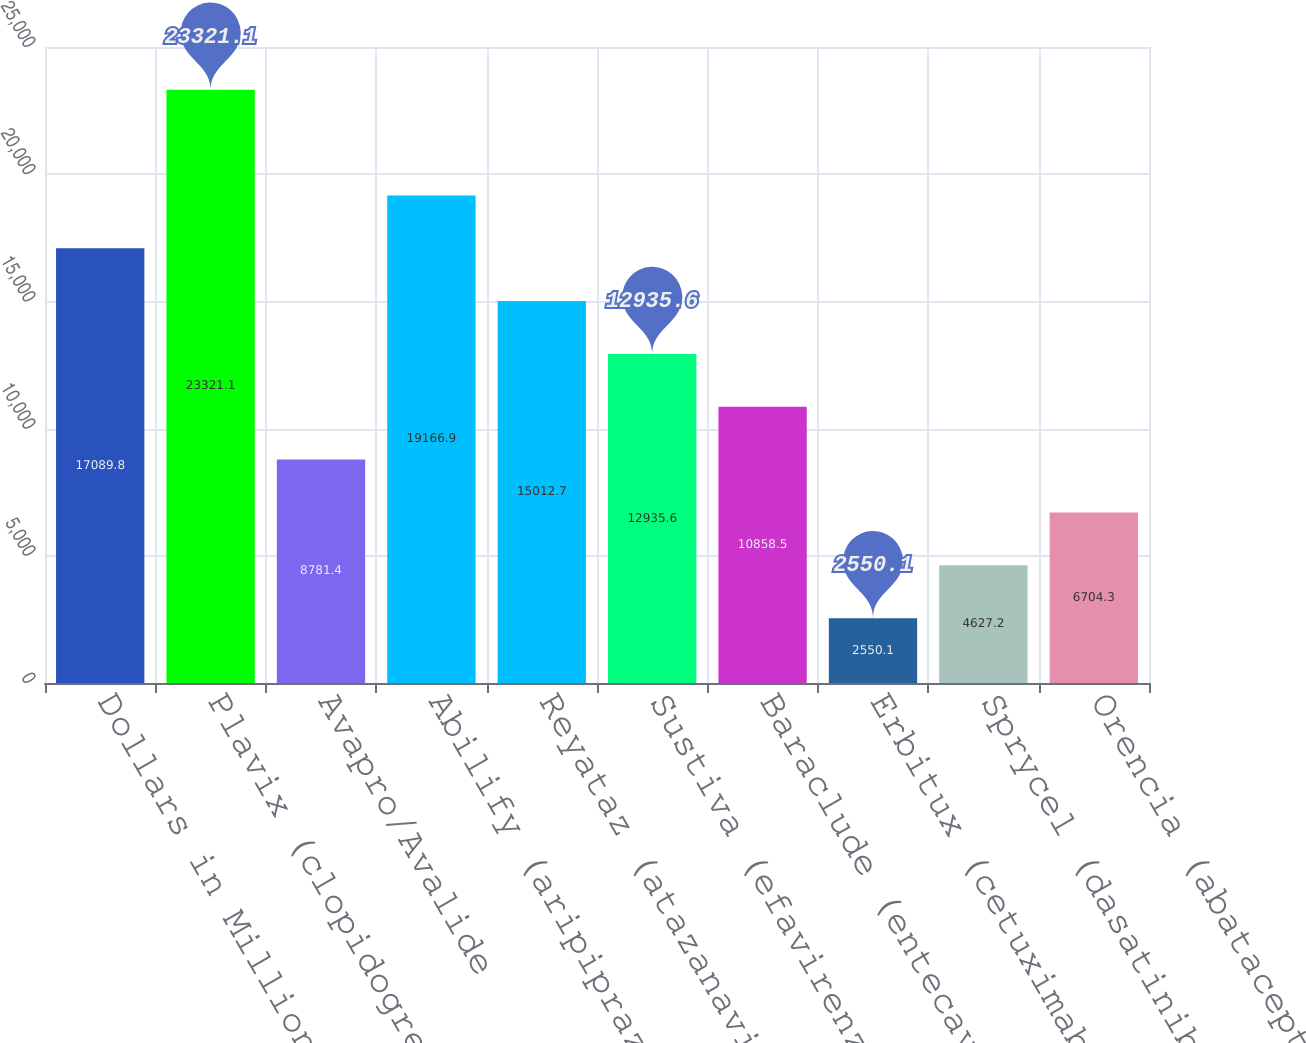Convert chart. <chart><loc_0><loc_0><loc_500><loc_500><bar_chart><fcel>Dollars in Millions<fcel>Plavix (clopidogrel bisulfate)<fcel>Avapro/Avalide<fcel>Abilify (aripiprazole)<fcel>Reyataz (atazanavir sulfate)<fcel>Sustiva (efavirenz) Franchise<fcel>Baraclude (entecavir)<fcel>Erbitux (cetuximab)<fcel>Sprycel (dasatinib)<fcel>Orencia (abatacept)<nl><fcel>17089.8<fcel>23321.1<fcel>8781.4<fcel>19166.9<fcel>15012.7<fcel>12935.6<fcel>10858.5<fcel>2550.1<fcel>4627.2<fcel>6704.3<nl></chart> 